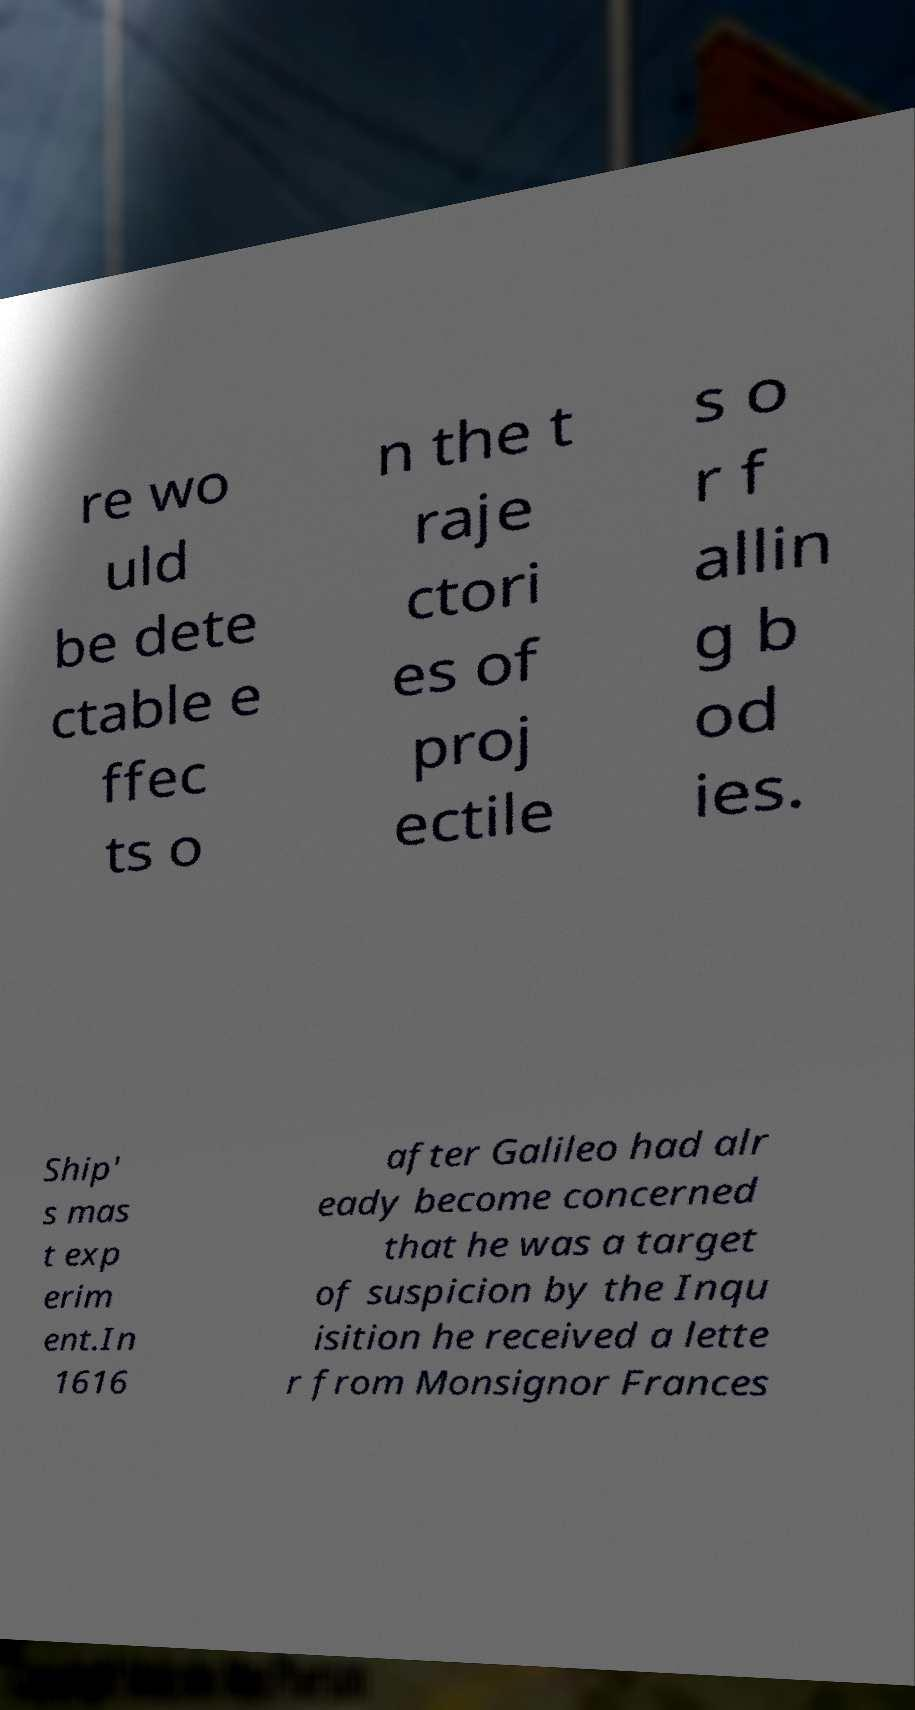Could you assist in decoding the text presented in this image and type it out clearly? re wo uld be dete ctable e ffec ts o n the t raje ctori es of proj ectile s o r f allin g b od ies. Ship' s mas t exp erim ent.In 1616 after Galileo had alr eady become concerned that he was a target of suspicion by the Inqu isition he received a lette r from Monsignor Frances 